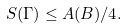Convert formula to latex. <formula><loc_0><loc_0><loc_500><loc_500>S ( \Gamma ) \leq A ( B ) / 4 .</formula> 